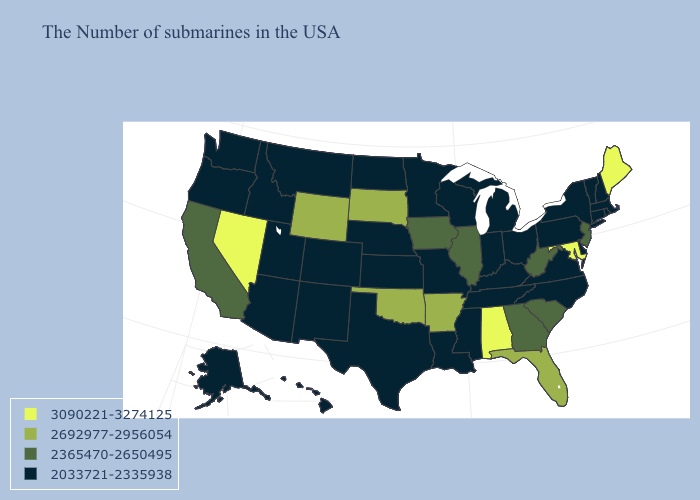What is the highest value in the USA?
Answer briefly. 3090221-3274125. Does Oklahoma have the same value as Wyoming?
Give a very brief answer. Yes. What is the lowest value in the South?
Be succinct. 2033721-2335938. Does New Mexico have the same value as New Hampshire?
Write a very short answer. Yes. Does Connecticut have the same value as Arkansas?
Keep it brief. No. Which states have the lowest value in the Northeast?
Short answer required. Massachusetts, Rhode Island, New Hampshire, Vermont, Connecticut, New York, Pennsylvania. Is the legend a continuous bar?
Write a very short answer. No. What is the value of Kentucky?
Quick response, please. 2033721-2335938. Does California have a lower value than South Dakota?
Quick response, please. Yes. What is the highest value in states that border Wyoming?
Concise answer only. 2692977-2956054. Does the map have missing data?
Short answer required. No. What is the lowest value in states that border Alabama?
Be succinct. 2033721-2335938. Among the states that border Colorado , which have the highest value?
Be succinct. Oklahoma, Wyoming. Name the states that have a value in the range 2033721-2335938?
Concise answer only. Massachusetts, Rhode Island, New Hampshire, Vermont, Connecticut, New York, Delaware, Pennsylvania, Virginia, North Carolina, Ohio, Michigan, Kentucky, Indiana, Tennessee, Wisconsin, Mississippi, Louisiana, Missouri, Minnesota, Kansas, Nebraska, Texas, North Dakota, Colorado, New Mexico, Utah, Montana, Arizona, Idaho, Washington, Oregon, Alaska, Hawaii. What is the lowest value in the West?
Keep it brief. 2033721-2335938. 